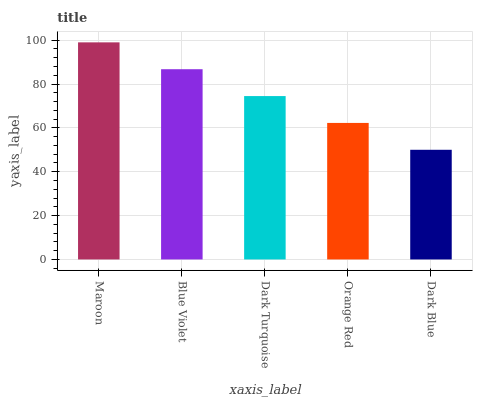Is Dark Blue the minimum?
Answer yes or no. Yes. Is Maroon the maximum?
Answer yes or no. Yes. Is Blue Violet the minimum?
Answer yes or no. No. Is Blue Violet the maximum?
Answer yes or no. No. Is Maroon greater than Blue Violet?
Answer yes or no. Yes. Is Blue Violet less than Maroon?
Answer yes or no. Yes. Is Blue Violet greater than Maroon?
Answer yes or no. No. Is Maroon less than Blue Violet?
Answer yes or no. No. Is Dark Turquoise the high median?
Answer yes or no. Yes. Is Dark Turquoise the low median?
Answer yes or no. Yes. Is Dark Blue the high median?
Answer yes or no. No. Is Maroon the low median?
Answer yes or no. No. 